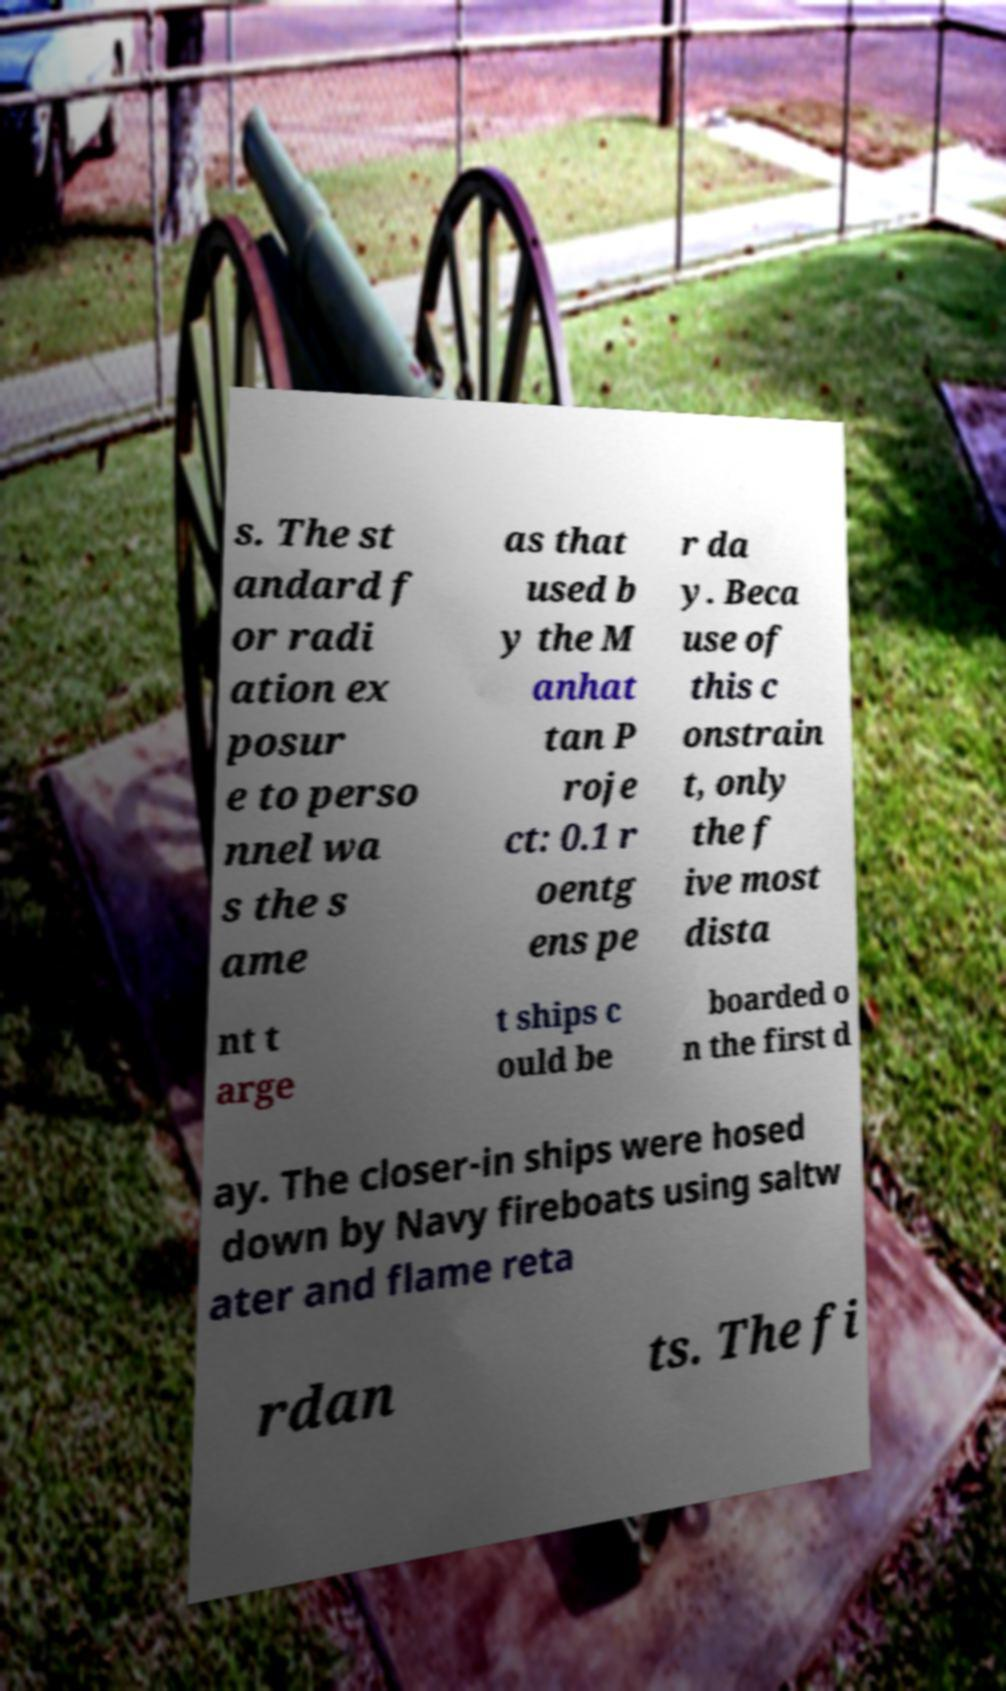Can you accurately transcribe the text from the provided image for me? s. The st andard f or radi ation ex posur e to perso nnel wa s the s ame as that used b y the M anhat tan P roje ct: 0.1 r oentg ens pe r da y. Beca use of this c onstrain t, only the f ive most dista nt t arge t ships c ould be boarded o n the first d ay. The closer-in ships were hosed down by Navy fireboats using saltw ater and flame reta rdan ts. The fi 